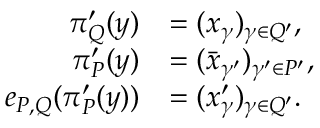<formula> <loc_0><loc_0><loc_500><loc_500>\begin{array} { r l } { \pi _ { Q } ^ { \prime } ( y ) } & { = ( x _ { \gamma } ) _ { \gamma \in Q ^ { \prime } } , } \\ { \pi _ { P } ^ { \prime } ( y ) } & { = ( \bar { x } _ { \gamma ^ { \prime } } ) _ { \gamma ^ { \prime } \in P ^ { \prime } } , } \\ { e _ { P , Q } ( \pi _ { P } ^ { \prime } ( y ) ) } & { = ( x _ { \gamma } ^ { \prime } ) _ { \gamma \in Q ^ { \prime } } . } \end{array}</formula> 